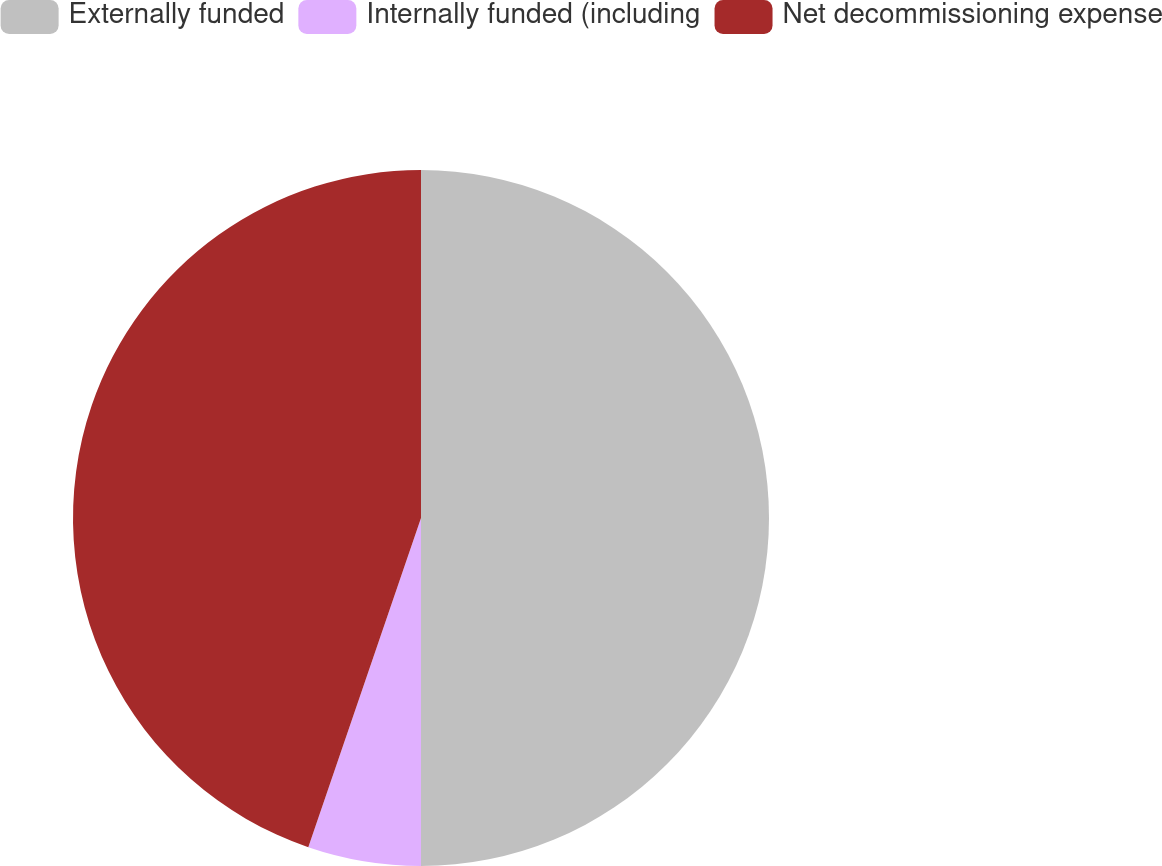Convert chart. <chart><loc_0><loc_0><loc_500><loc_500><pie_chart><fcel>Externally funded<fcel>Internally funded (including<fcel>Net decommissioning expense<nl><fcel>50.0%<fcel>5.25%<fcel>44.75%<nl></chart> 